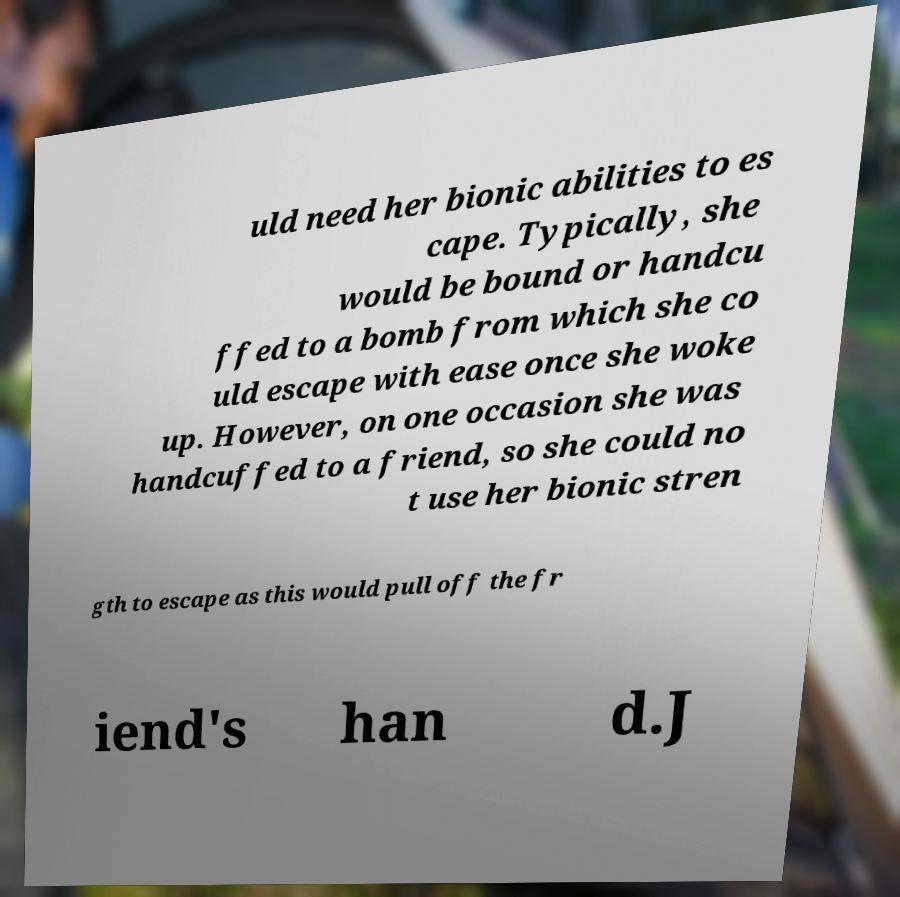I need the written content from this picture converted into text. Can you do that? uld need her bionic abilities to es cape. Typically, she would be bound or handcu ffed to a bomb from which she co uld escape with ease once she woke up. However, on one occasion she was handcuffed to a friend, so she could no t use her bionic stren gth to escape as this would pull off the fr iend's han d.J 